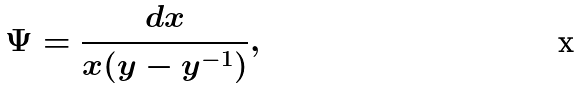<formula> <loc_0><loc_0><loc_500><loc_500>\Psi = \frac { d x } { x ( y - y ^ { - 1 } ) } ,</formula> 